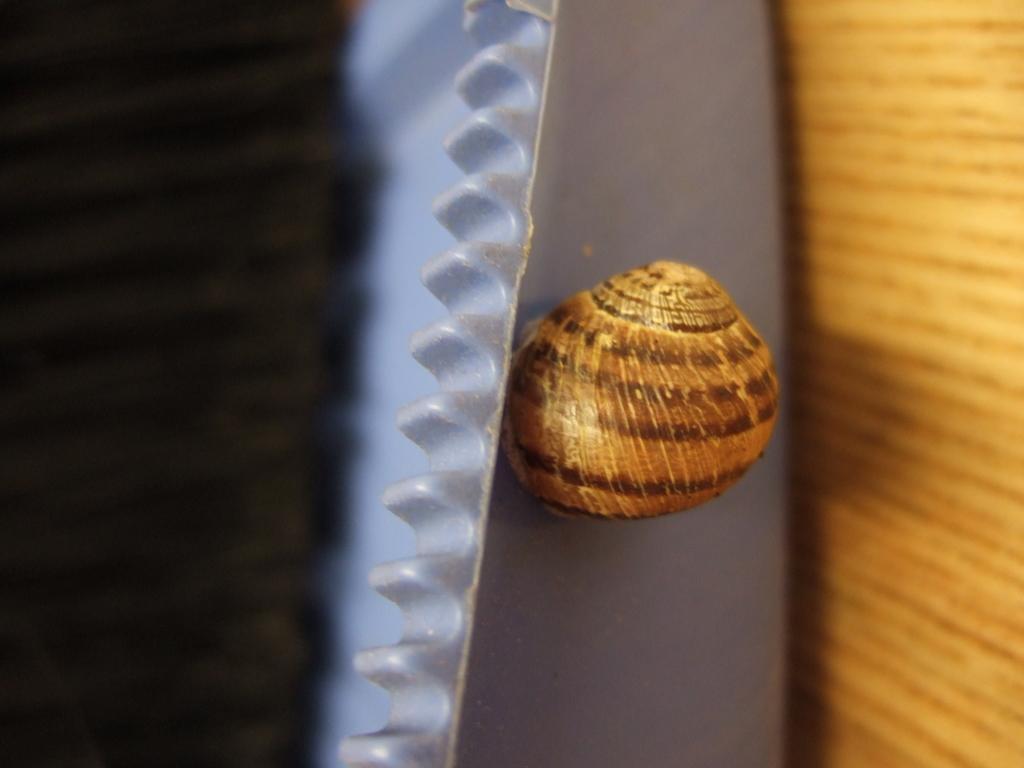Could you give a brief overview of what you see in this image? In this image I can see a snail on an object which is looking like a tray. On the right side, I can see a wooden object. 